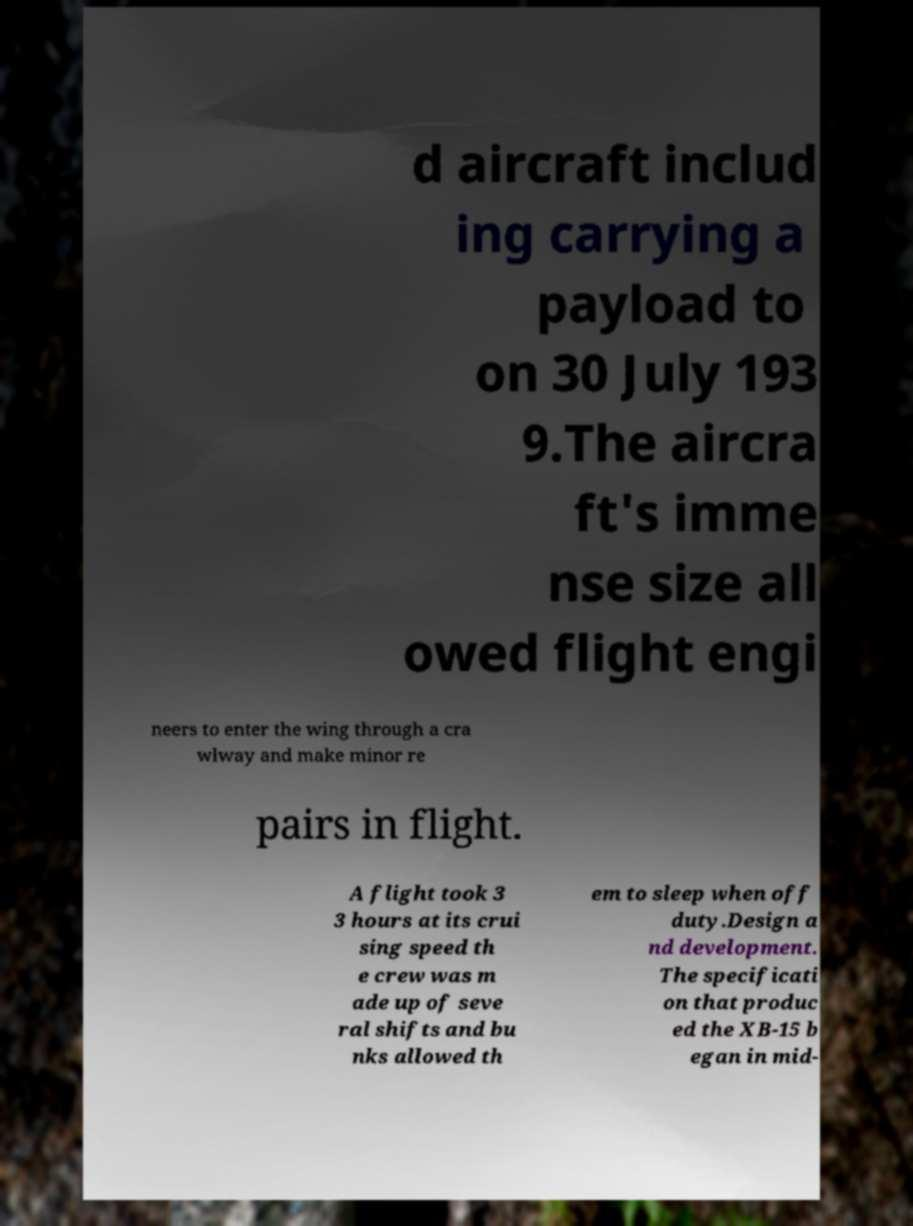Can you accurately transcribe the text from the provided image for me? d aircraft includ ing carrying a payload to on 30 July 193 9.The aircra ft's imme nse size all owed flight engi neers to enter the wing through a cra wlway and make minor re pairs in flight. A flight took 3 3 hours at its crui sing speed th e crew was m ade up of seve ral shifts and bu nks allowed th em to sleep when off duty.Design a nd development. The specificati on that produc ed the XB-15 b egan in mid- 